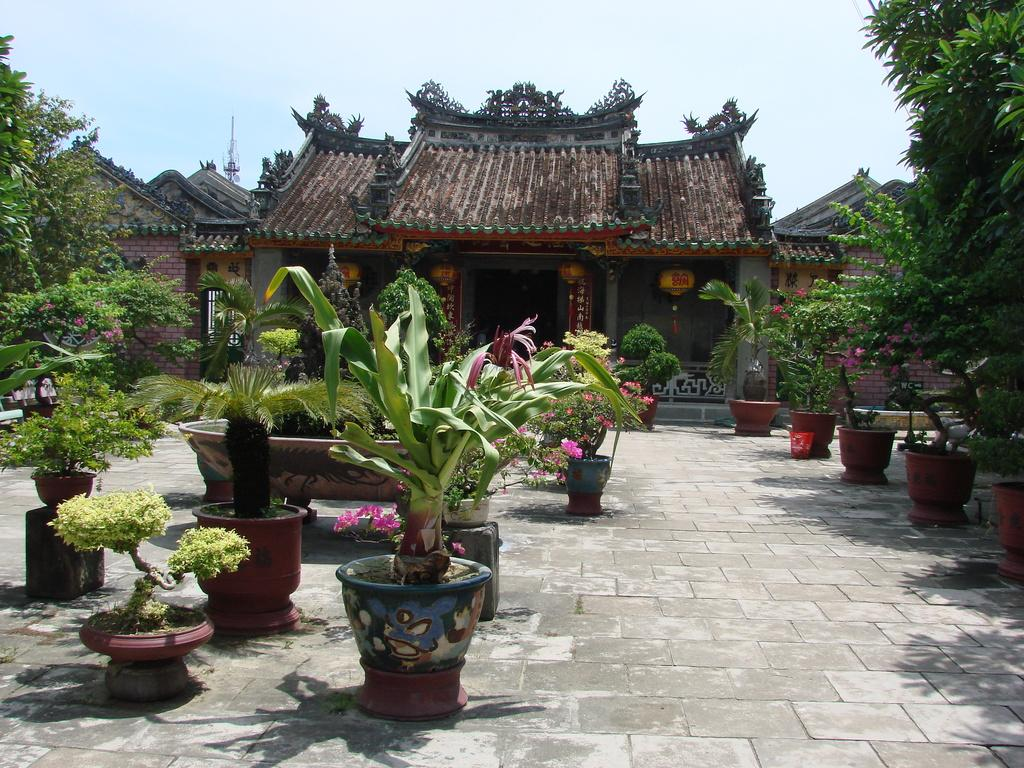What type of building is in the image? There is a house in the image. What is located in front of the house? There are house plants and trees in front of the house. Can you describe the vegetation visible in the image? There are trees visible in the image. What else can be seen in the image besides the house and trees? There is a pole in the image. What is visible in the background of the image? The sky is visible in the background of the image. What type of record is being played in the image? There is no record or music player present in the image. What type of relation is depicted between the house and the trees in the image? The image does not depict a relation between the house and the trees; it simply shows them as separate elements in the scene. 